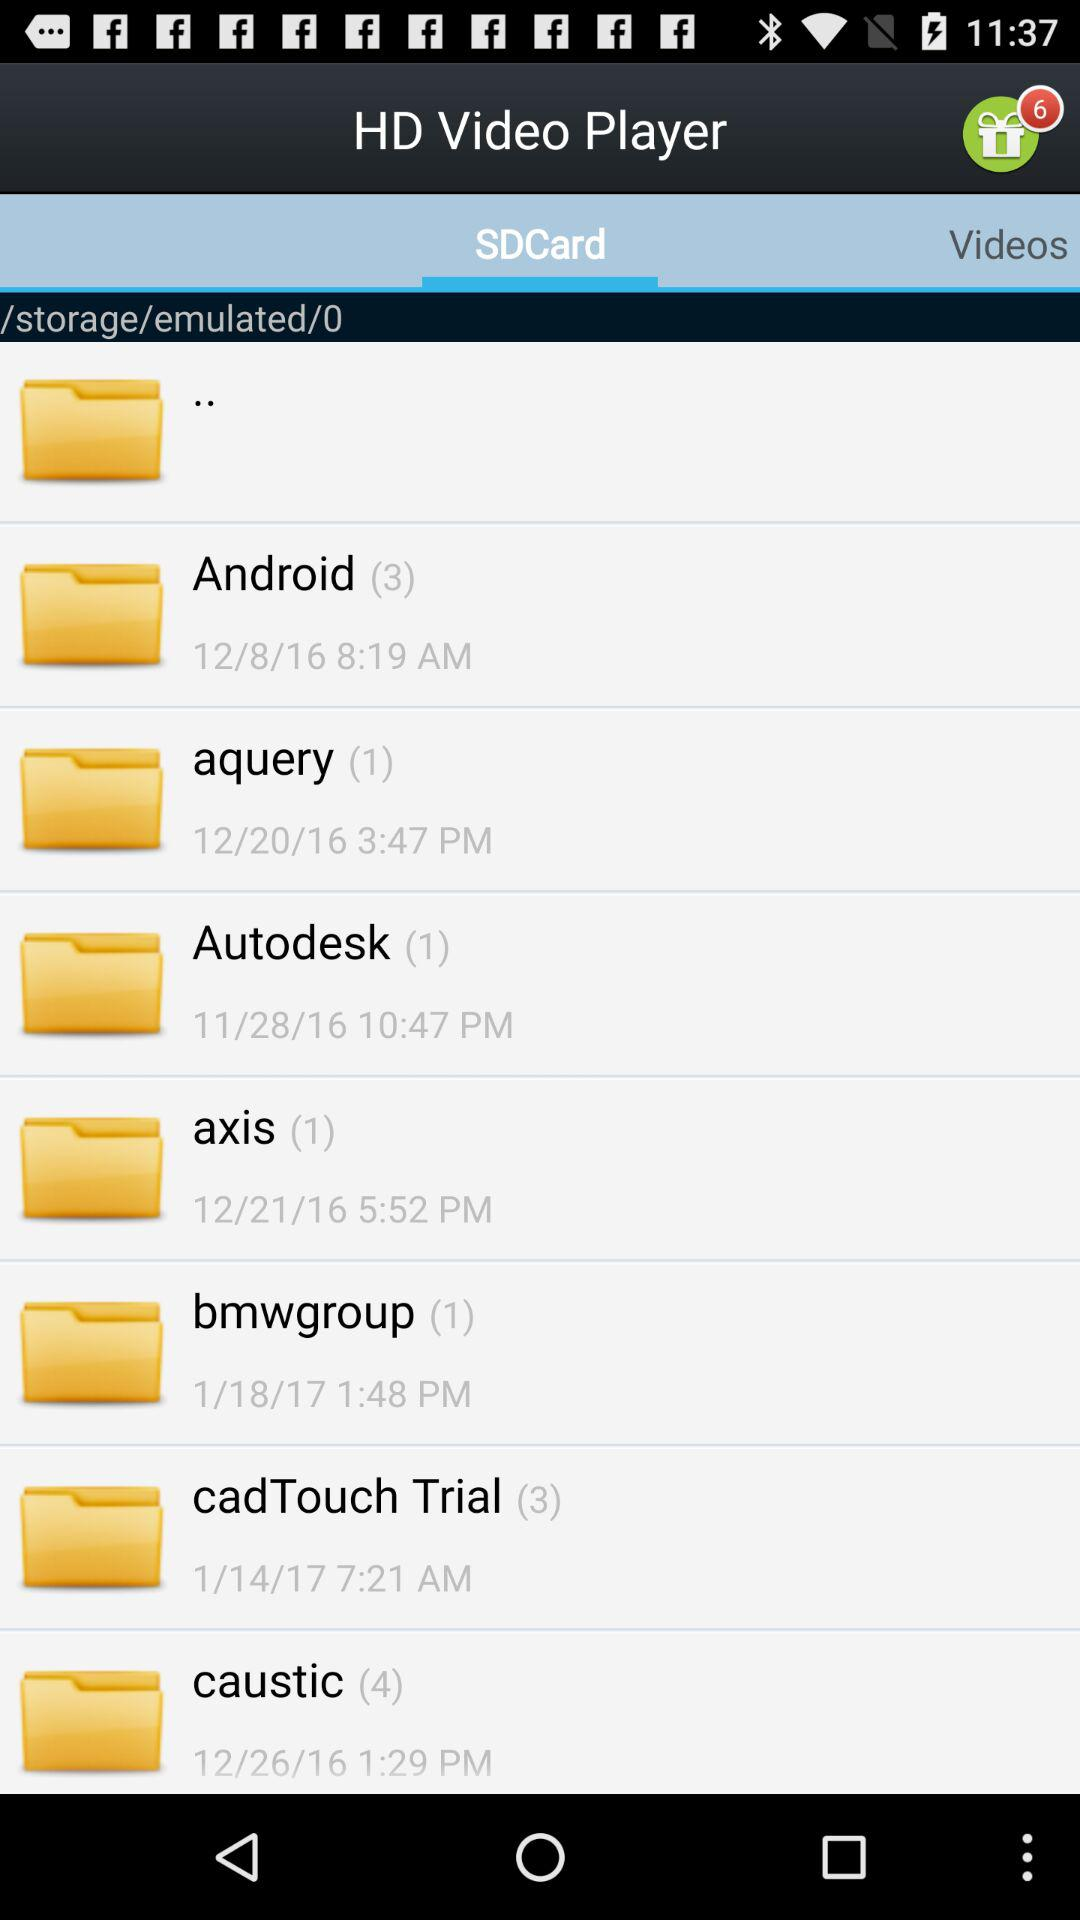What is the selected time for the aquery? The time for the aquery is 3:47 pm. 